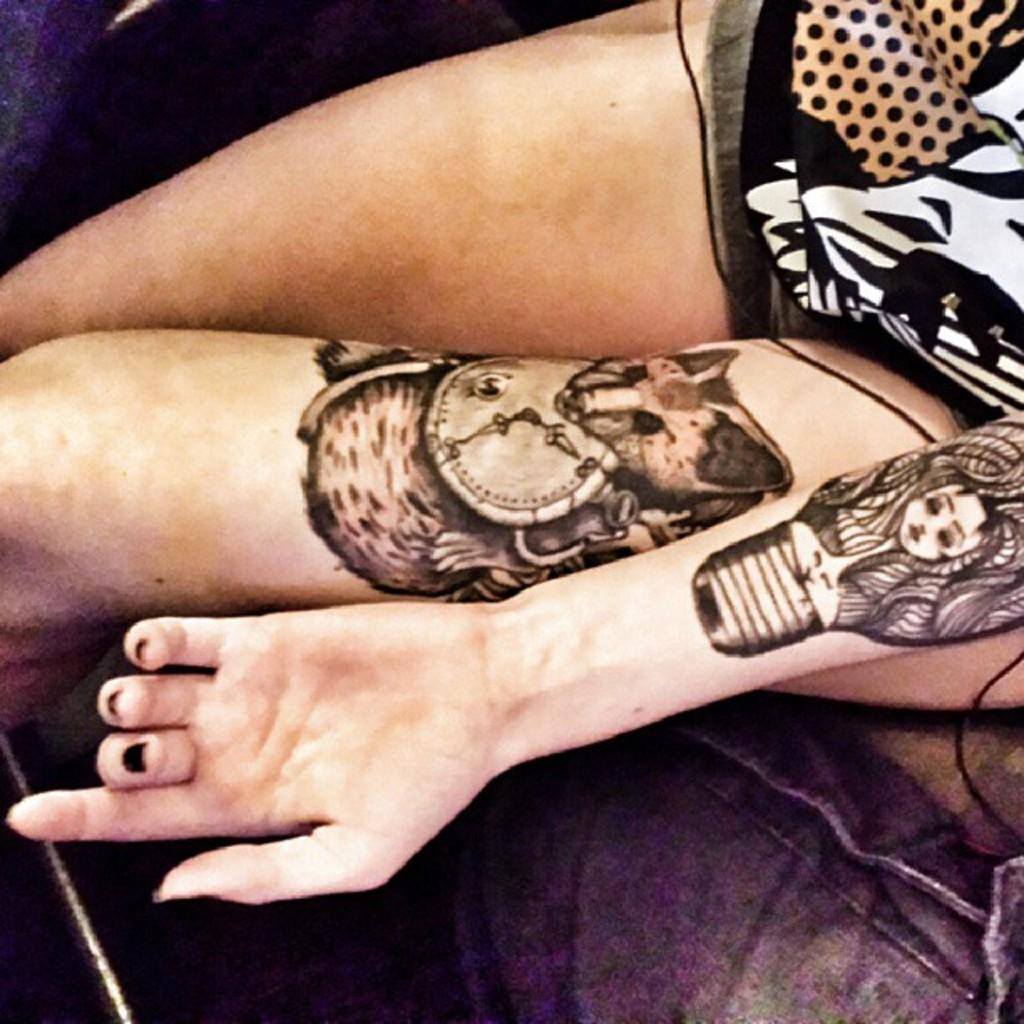What is the person in the image doing? The person is sitting in the image. Can you describe any visible tattoos on the person? The person has tattoos on their hand and thigh. What type of rod can be seen in the person's hand in the image? There is no rod present in the person's hand in the image. Can you tell me how many tigers are visible in the image? There are no tigers present in the image. 